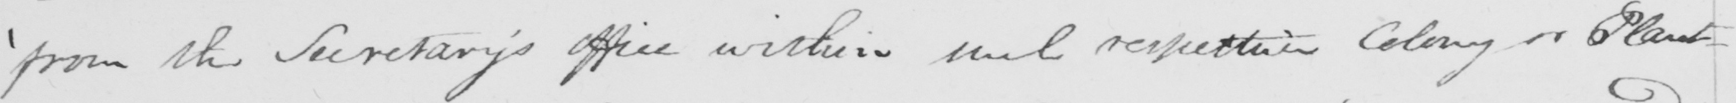What does this handwritten line say? ' from the Secretary ' s office within such respective Colony or Plant- 